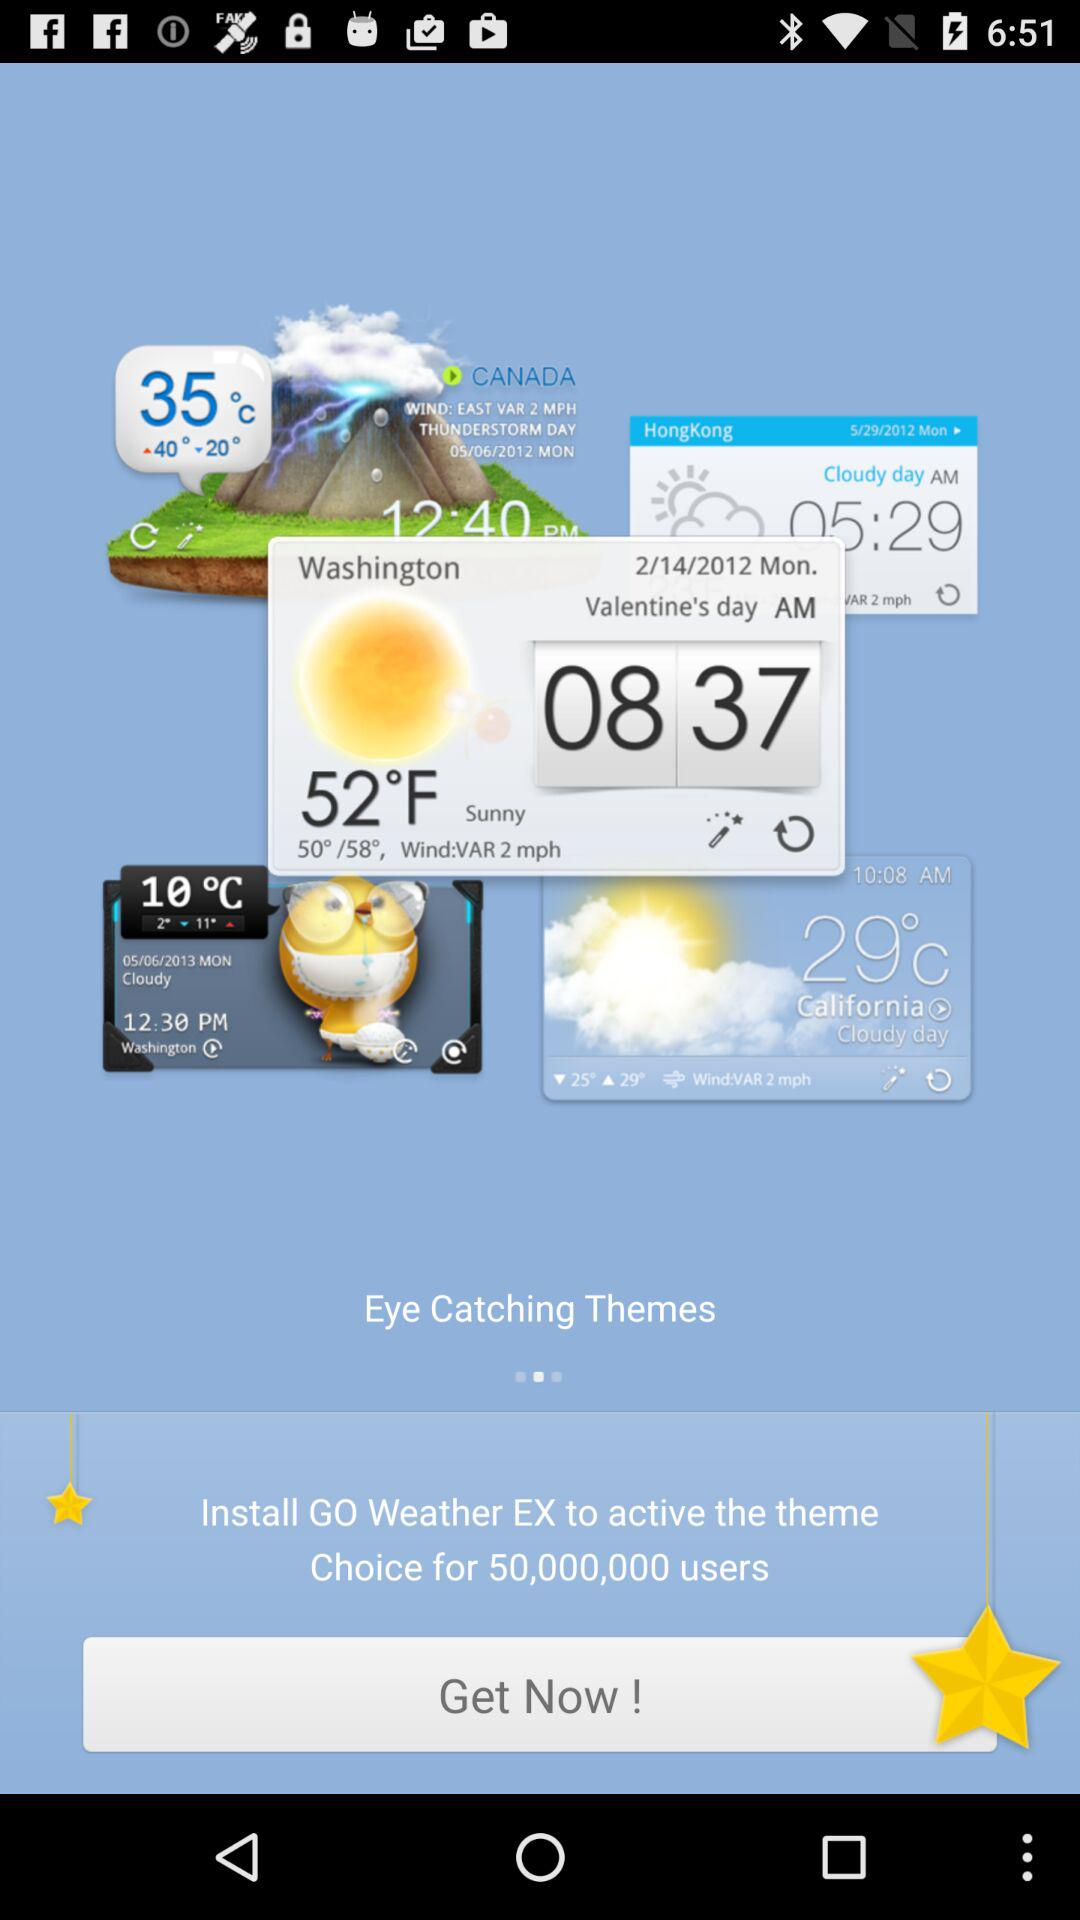What is the unit of temperature? The units of temperature are °C and °F. 